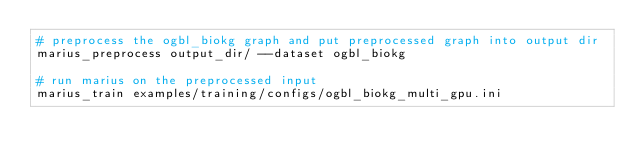Convert code to text. <code><loc_0><loc_0><loc_500><loc_500><_Bash_># preprocess the ogbl_biokg graph and put preprocessed graph into output dir
marius_preprocess output_dir/ --dataset ogbl_biokg

# run marius on the preprocessed input
marius_train examples/training/configs/ogbl_biokg_multi_gpu.ini</code> 